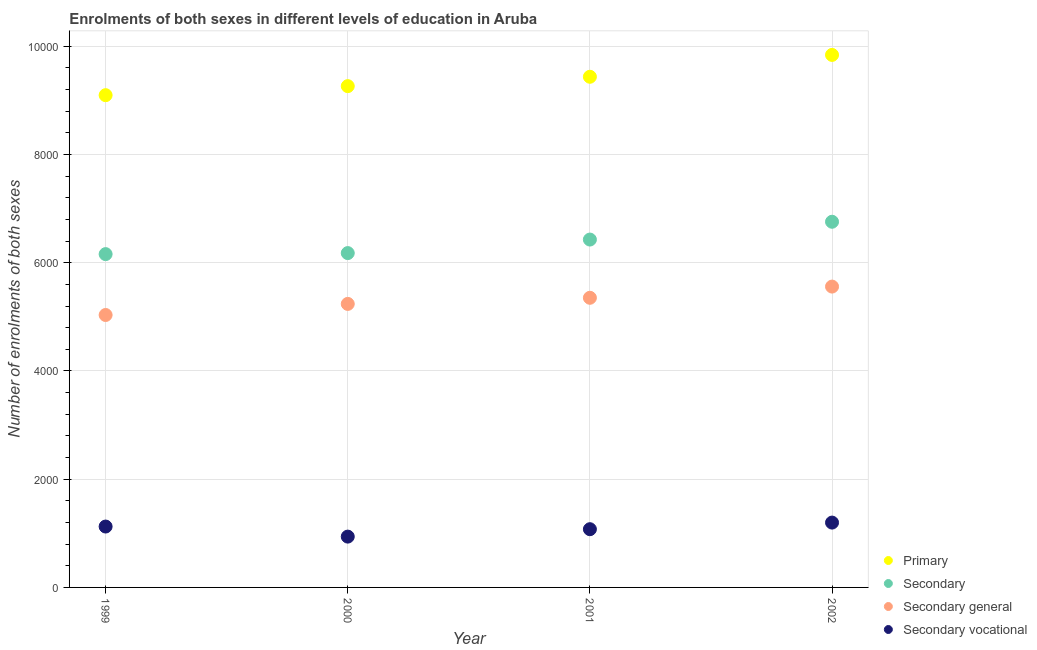How many different coloured dotlines are there?
Your answer should be compact. 4. Is the number of dotlines equal to the number of legend labels?
Keep it short and to the point. Yes. What is the number of enrolments in primary education in 2000?
Make the answer very short. 9263. Across all years, what is the maximum number of enrolments in secondary general education?
Your answer should be compact. 5559. Across all years, what is the minimum number of enrolments in secondary education?
Provide a succinct answer. 6159. What is the total number of enrolments in secondary education in the graph?
Provide a short and direct response. 2.55e+04. What is the difference between the number of enrolments in secondary education in 2001 and that in 2002?
Keep it short and to the point. -329. What is the difference between the number of enrolments in secondary vocational education in 2001 and the number of enrolments in secondary education in 1999?
Your response must be concise. -5083. What is the average number of enrolments in secondary general education per year?
Offer a very short reply. 5296. In the year 2002, what is the difference between the number of enrolments in secondary education and number of enrolments in secondary general education?
Provide a succinct answer. 1198. In how many years, is the number of enrolments in secondary education greater than 8000?
Provide a succinct answer. 0. What is the ratio of the number of enrolments in secondary education in 1999 to that in 2000?
Make the answer very short. 1. Is the difference between the number of enrolments in secondary vocational education in 2000 and 2001 greater than the difference between the number of enrolments in primary education in 2000 and 2001?
Keep it short and to the point. Yes. What is the difference between the highest and the second highest number of enrolments in primary education?
Make the answer very short. 404. What is the difference between the highest and the lowest number of enrolments in secondary education?
Your answer should be compact. 598. Is the sum of the number of enrolments in secondary vocational education in 1999 and 2000 greater than the maximum number of enrolments in primary education across all years?
Make the answer very short. No. Is it the case that in every year, the sum of the number of enrolments in primary education and number of enrolments in secondary education is greater than the number of enrolments in secondary general education?
Give a very brief answer. Yes. Is the number of enrolments in primary education strictly greater than the number of enrolments in secondary education over the years?
Ensure brevity in your answer.  Yes. How many dotlines are there?
Your answer should be very brief. 4. How many years are there in the graph?
Ensure brevity in your answer.  4. Are the values on the major ticks of Y-axis written in scientific E-notation?
Provide a succinct answer. No. Does the graph contain any zero values?
Ensure brevity in your answer.  No. Does the graph contain grids?
Offer a terse response. Yes. What is the title of the graph?
Offer a terse response. Enrolments of both sexes in different levels of education in Aruba. Does "Industry" appear as one of the legend labels in the graph?
Offer a very short reply. No. What is the label or title of the Y-axis?
Ensure brevity in your answer.  Number of enrolments of both sexes. What is the Number of enrolments of both sexes in Primary in 1999?
Ensure brevity in your answer.  9096. What is the Number of enrolments of both sexes of Secondary in 1999?
Offer a very short reply. 6159. What is the Number of enrolments of both sexes of Secondary general in 1999?
Provide a succinct answer. 5034. What is the Number of enrolments of both sexes in Secondary vocational in 1999?
Keep it short and to the point. 1125. What is the Number of enrolments of both sexes in Primary in 2000?
Offer a very short reply. 9263. What is the Number of enrolments of both sexes in Secondary in 2000?
Keep it short and to the point. 6178. What is the Number of enrolments of both sexes of Secondary general in 2000?
Provide a succinct answer. 5239. What is the Number of enrolments of both sexes of Secondary vocational in 2000?
Your answer should be compact. 939. What is the Number of enrolments of both sexes of Primary in 2001?
Offer a very short reply. 9436. What is the Number of enrolments of both sexes in Secondary in 2001?
Provide a short and direct response. 6428. What is the Number of enrolments of both sexes in Secondary general in 2001?
Provide a succinct answer. 5352. What is the Number of enrolments of both sexes in Secondary vocational in 2001?
Make the answer very short. 1076. What is the Number of enrolments of both sexes in Primary in 2002?
Make the answer very short. 9840. What is the Number of enrolments of both sexes in Secondary in 2002?
Your answer should be very brief. 6757. What is the Number of enrolments of both sexes in Secondary general in 2002?
Your response must be concise. 5559. What is the Number of enrolments of both sexes in Secondary vocational in 2002?
Provide a succinct answer. 1198. Across all years, what is the maximum Number of enrolments of both sexes of Primary?
Provide a short and direct response. 9840. Across all years, what is the maximum Number of enrolments of both sexes of Secondary?
Your answer should be compact. 6757. Across all years, what is the maximum Number of enrolments of both sexes in Secondary general?
Offer a terse response. 5559. Across all years, what is the maximum Number of enrolments of both sexes in Secondary vocational?
Provide a short and direct response. 1198. Across all years, what is the minimum Number of enrolments of both sexes in Primary?
Your response must be concise. 9096. Across all years, what is the minimum Number of enrolments of both sexes in Secondary?
Offer a very short reply. 6159. Across all years, what is the minimum Number of enrolments of both sexes in Secondary general?
Make the answer very short. 5034. Across all years, what is the minimum Number of enrolments of both sexes of Secondary vocational?
Your answer should be compact. 939. What is the total Number of enrolments of both sexes in Primary in the graph?
Your answer should be compact. 3.76e+04. What is the total Number of enrolments of both sexes in Secondary in the graph?
Your answer should be compact. 2.55e+04. What is the total Number of enrolments of both sexes in Secondary general in the graph?
Give a very brief answer. 2.12e+04. What is the total Number of enrolments of both sexes of Secondary vocational in the graph?
Give a very brief answer. 4338. What is the difference between the Number of enrolments of both sexes of Primary in 1999 and that in 2000?
Keep it short and to the point. -167. What is the difference between the Number of enrolments of both sexes in Secondary general in 1999 and that in 2000?
Offer a very short reply. -205. What is the difference between the Number of enrolments of both sexes of Secondary vocational in 1999 and that in 2000?
Give a very brief answer. 186. What is the difference between the Number of enrolments of both sexes in Primary in 1999 and that in 2001?
Provide a short and direct response. -340. What is the difference between the Number of enrolments of both sexes of Secondary in 1999 and that in 2001?
Ensure brevity in your answer.  -269. What is the difference between the Number of enrolments of both sexes of Secondary general in 1999 and that in 2001?
Your response must be concise. -318. What is the difference between the Number of enrolments of both sexes of Primary in 1999 and that in 2002?
Offer a terse response. -744. What is the difference between the Number of enrolments of both sexes in Secondary in 1999 and that in 2002?
Offer a very short reply. -598. What is the difference between the Number of enrolments of both sexes in Secondary general in 1999 and that in 2002?
Offer a terse response. -525. What is the difference between the Number of enrolments of both sexes of Secondary vocational in 1999 and that in 2002?
Keep it short and to the point. -73. What is the difference between the Number of enrolments of both sexes of Primary in 2000 and that in 2001?
Provide a short and direct response. -173. What is the difference between the Number of enrolments of both sexes in Secondary in 2000 and that in 2001?
Give a very brief answer. -250. What is the difference between the Number of enrolments of both sexes of Secondary general in 2000 and that in 2001?
Your answer should be compact. -113. What is the difference between the Number of enrolments of both sexes of Secondary vocational in 2000 and that in 2001?
Your answer should be very brief. -137. What is the difference between the Number of enrolments of both sexes of Primary in 2000 and that in 2002?
Provide a succinct answer. -577. What is the difference between the Number of enrolments of both sexes of Secondary in 2000 and that in 2002?
Keep it short and to the point. -579. What is the difference between the Number of enrolments of both sexes in Secondary general in 2000 and that in 2002?
Give a very brief answer. -320. What is the difference between the Number of enrolments of both sexes in Secondary vocational in 2000 and that in 2002?
Your answer should be compact. -259. What is the difference between the Number of enrolments of both sexes of Primary in 2001 and that in 2002?
Ensure brevity in your answer.  -404. What is the difference between the Number of enrolments of both sexes of Secondary in 2001 and that in 2002?
Your response must be concise. -329. What is the difference between the Number of enrolments of both sexes in Secondary general in 2001 and that in 2002?
Provide a short and direct response. -207. What is the difference between the Number of enrolments of both sexes of Secondary vocational in 2001 and that in 2002?
Offer a very short reply. -122. What is the difference between the Number of enrolments of both sexes of Primary in 1999 and the Number of enrolments of both sexes of Secondary in 2000?
Keep it short and to the point. 2918. What is the difference between the Number of enrolments of both sexes in Primary in 1999 and the Number of enrolments of both sexes in Secondary general in 2000?
Give a very brief answer. 3857. What is the difference between the Number of enrolments of both sexes of Primary in 1999 and the Number of enrolments of both sexes of Secondary vocational in 2000?
Keep it short and to the point. 8157. What is the difference between the Number of enrolments of both sexes in Secondary in 1999 and the Number of enrolments of both sexes in Secondary general in 2000?
Your answer should be very brief. 920. What is the difference between the Number of enrolments of both sexes in Secondary in 1999 and the Number of enrolments of both sexes in Secondary vocational in 2000?
Keep it short and to the point. 5220. What is the difference between the Number of enrolments of both sexes in Secondary general in 1999 and the Number of enrolments of both sexes in Secondary vocational in 2000?
Give a very brief answer. 4095. What is the difference between the Number of enrolments of both sexes in Primary in 1999 and the Number of enrolments of both sexes in Secondary in 2001?
Offer a very short reply. 2668. What is the difference between the Number of enrolments of both sexes in Primary in 1999 and the Number of enrolments of both sexes in Secondary general in 2001?
Your answer should be compact. 3744. What is the difference between the Number of enrolments of both sexes of Primary in 1999 and the Number of enrolments of both sexes of Secondary vocational in 2001?
Give a very brief answer. 8020. What is the difference between the Number of enrolments of both sexes in Secondary in 1999 and the Number of enrolments of both sexes in Secondary general in 2001?
Give a very brief answer. 807. What is the difference between the Number of enrolments of both sexes in Secondary in 1999 and the Number of enrolments of both sexes in Secondary vocational in 2001?
Provide a succinct answer. 5083. What is the difference between the Number of enrolments of both sexes in Secondary general in 1999 and the Number of enrolments of both sexes in Secondary vocational in 2001?
Give a very brief answer. 3958. What is the difference between the Number of enrolments of both sexes in Primary in 1999 and the Number of enrolments of both sexes in Secondary in 2002?
Offer a terse response. 2339. What is the difference between the Number of enrolments of both sexes in Primary in 1999 and the Number of enrolments of both sexes in Secondary general in 2002?
Your answer should be compact. 3537. What is the difference between the Number of enrolments of both sexes of Primary in 1999 and the Number of enrolments of both sexes of Secondary vocational in 2002?
Offer a terse response. 7898. What is the difference between the Number of enrolments of both sexes of Secondary in 1999 and the Number of enrolments of both sexes of Secondary general in 2002?
Keep it short and to the point. 600. What is the difference between the Number of enrolments of both sexes in Secondary in 1999 and the Number of enrolments of both sexes in Secondary vocational in 2002?
Offer a very short reply. 4961. What is the difference between the Number of enrolments of both sexes in Secondary general in 1999 and the Number of enrolments of both sexes in Secondary vocational in 2002?
Provide a short and direct response. 3836. What is the difference between the Number of enrolments of both sexes of Primary in 2000 and the Number of enrolments of both sexes of Secondary in 2001?
Your response must be concise. 2835. What is the difference between the Number of enrolments of both sexes in Primary in 2000 and the Number of enrolments of both sexes in Secondary general in 2001?
Provide a short and direct response. 3911. What is the difference between the Number of enrolments of both sexes in Primary in 2000 and the Number of enrolments of both sexes in Secondary vocational in 2001?
Your answer should be compact. 8187. What is the difference between the Number of enrolments of both sexes in Secondary in 2000 and the Number of enrolments of both sexes in Secondary general in 2001?
Keep it short and to the point. 826. What is the difference between the Number of enrolments of both sexes in Secondary in 2000 and the Number of enrolments of both sexes in Secondary vocational in 2001?
Your response must be concise. 5102. What is the difference between the Number of enrolments of both sexes in Secondary general in 2000 and the Number of enrolments of both sexes in Secondary vocational in 2001?
Your response must be concise. 4163. What is the difference between the Number of enrolments of both sexes of Primary in 2000 and the Number of enrolments of both sexes of Secondary in 2002?
Offer a very short reply. 2506. What is the difference between the Number of enrolments of both sexes in Primary in 2000 and the Number of enrolments of both sexes in Secondary general in 2002?
Ensure brevity in your answer.  3704. What is the difference between the Number of enrolments of both sexes in Primary in 2000 and the Number of enrolments of both sexes in Secondary vocational in 2002?
Provide a succinct answer. 8065. What is the difference between the Number of enrolments of both sexes in Secondary in 2000 and the Number of enrolments of both sexes in Secondary general in 2002?
Give a very brief answer. 619. What is the difference between the Number of enrolments of both sexes of Secondary in 2000 and the Number of enrolments of both sexes of Secondary vocational in 2002?
Keep it short and to the point. 4980. What is the difference between the Number of enrolments of both sexes in Secondary general in 2000 and the Number of enrolments of both sexes in Secondary vocational in 2002?
Offer a terse response. 4041. What is the difference between the Number of enrolments of both sexes of Primary in 2001 and the Number of enrolments of both sexes of Secondary in 2002?
Offer a very short reply. 2679. What is the difference between the Number of enrolments of both sexes of Primary in 2001 and the Number of enrolments of both sexes of Secondary general in 2002?
Provide a succinct answer. 3877. What is the difference between the Number of enrolments of both sexes of Primary in 2001 and the Number of enrolments of both sexes of Secondary vocational in 2002?
Offer a terse response. 8238. What is the difference between the Number of enrolments of both sexes in Secondary in 2001 and the Number of enrolments of both sexes in Secondary general in 2002?
Your answer should be very brief. 869. What is the difference between the Number of enrolments of both sexes in Secondary in 2001 and the Number of enrolments of both sexes in Secondary vocational in 2002?
Give a very brief answer. 5230. What is the difference between the Number of enrolments of both sexes of Secondary general in 2001 and the Number of enrolments of both sexes of Secondary vocational in 2002?
Offer a terse response. 4154. What is the average Number of enrolments of both sexes in Primary per year?
Ensure brevity in your answer.  9408.75. What is the average Number of enrolments of both sexes in Secondary per year?
Give a very brief answer. 6380.5. What is the average Number of enrolments of both sexes in Secondary general per year?
Make the answer very short. 5296. What is the average Number of enrolments of both sexes in Secondary vocational per year?
Your answer should be very brief. 1084.5. In the year 1999, what is the difference between the Number of enrolments of both sexes in Primary and Number of enrolments of both sexes in Secondary?
Provide a succinct answer. 2937. In the year 1999, what is the difference between the Number of enrolments of both sexes of Primary and Number of enrolments of both sexes of Secondary general?
Ensure brevity in your answer.  4062. In the year 1999, what is the difference between the Number of enrolments of both sexes in Primary and Number of enrolments of both sexes in Secondary vocational?
Your answer should be very brief. 7971. In the year 1999, what is the difference between the Number of enrolments of both sexes of Secondary and Number of enrolments of both sexes of Secondary general?
Give a very brief answer. 1125. In the year 1999, what is the difference between the Number of enrolments of both sexes in Secondary and Number of enrolments of both sexes in Secondary vocational?
Your response must be concise. 5034. In the year 1999, what is the difference between the Number of enrolments of both sexes in Secondary general and Number of enrolments of both sexes in Secondary vocational?
Your answer should be compact. 3909. In the year 2000, what is the difference between the Number of enrolments of both sexes of Primary and Number of enrolments of both sexes of Secondary?
Give a very brief answer. 3085. In the year 2000, what is the difference between the Number of enrolments of both sexes of Primary and Number of enrolments of both sexes of Secondary general?
Provide a succinct answer. 4024. In the year 2000, what is the difference between the Number of enrolments of both sexes of Primary and Number of enrolments of both sexes of Secondary vocational?
Your response must be concise. 8324. In the year 2000, what is the difference between the Number of enrolments of both sexes of Secondary and Number of enrolments of both sexes of Secondary general?
Provide a succinct answer. 939. In the year 2000, what is the difference between the Number of enrolments of both sexes of Secondary and Number of enrolments of both sexes of Secondary vocational?
Your answer should be very brief. 5239. In the year 2000, what is the difference between the Number of enrolments of both sexes of Secondary general and Number of enrolments of both sexes of Secondary vocational?
Offer a very short reply. 4300. In the year 2001, what is the difference between the Number of enrolments of both sexes of Primary and Number of enrolments of both sexes of Secondary?
Your answer should be very brief. 3008. In the year 2001, what is the difference between the Number of enrolments of both sexes in Primary and Number of enrolments of both sexes in Secondary general?
Ensure brevity in your answer.  4084. In the year 2001, what is the difference between the Number of enrolments of both sexes of Primary and Number of enrolments of both sexes of Secondary vocational?
Provide a succinct answer. 8360. In the year 2001, what is the difference between the Number of enrolments of both sexes in Secondary and Number of enrolments of both sexes in Secondary general?
Your response must be concise. 1076. In the year 2001, what is the difference between the Number of enrolments of both sexes of Secondary and Number of enrolments of both sexes of Secondary vocational?
Your answer should be compact. 5352. In the year 2001, what is the difference between the Number of enrolments of both sexes in Secondary general and Number of enrolments of both sexes in Secondary vocational?
Provide a succinct answer. 4276. In the year 2002, what is the difference between the Number of enrolments of both sexes in Primary and Number of enrolments of both sexes in Secondary?
Your answer should be compact. 3083. In the year 2002, what is the difference between the Number of enrolments of both sexes in Primary and Number of enrolments of both sexes in Secondary general?
Keep it short and to the point. 4281. In the year 2002, what is the difference between the Number of enrolments of both sexes of Primary and Number of enrolments of both sexes of Secondary vocational?
Provide a short and direct response. 8642. In the year 2002, what is the difference between the Number of enrolments of both sexes in Secondary and Number of enrolments of both sexes in Secondary general?
Offer a terse response. 1198. In the year 2002, what is the difference between the Number of enrolments of both sexes of Secondary and Number of enrolments of both sexes of Secondary vocational?
Your answer should be compact. 5559. In the year 2002, what is the difference between the Number of enrolments of both sexes in Secondary general and Number of enrolments of both sexes in Secondary vocational?
Your answer should be very brief. 4361. What is the ratio of the Number of enrolments of both sexes in Primary in 1999 to that in 2000?
Provide a succinct answer. 0.98. What is the ratio of the Number of enrolments of both sexes in Secondary general in 1999 to that in 2000?
Provide a short and direct response. 0.96. What is the ratio of the Number of enrolments of both sexes in Secondary vocational in 1999 to that in 2000?
Ensure brevity in your answer.  1.2. What is the ratio of the Number of enrolments of both sexes in Secondary in 1999 to that in 2001?
Keep it short and to the point. 0.96. What is the ratio of the Number of enrolments of both sexes of Secondary general in 1999 to that in 2001?
Your response must be concise. 0.94. What is the ratio of the Number of enrolments of both sexes in Secondary vocational in 1999 to that in 2001?
Your answer should be compact. 1.05. What is the ratio of the Number of enrolments of both sexes of Primary in 1999 to that in 2002?
Your response must be concise. 0.92. What is the ratio of the Number of enrolments of both sexes of Secondary in 1999 to that in 2002?
Your answer should be compact. 0.91. What is the ratio of the Number of enrolments of both sexes of Secondary general in 1999 to that in 2002?
Your answer should be very brief. 0.91. What is the ratio of the Number of enrolments of both sexes of Secondary vocational in 1999 to that in 2002?
Ensure brevity in your answer.  0.94. What is the ratio of the Number of enrolments of both sexes of Primary in 2000 to that in 2001?
Your answer should be very brief. 0.98. What is the ratio of the Number of enrolments of both sexes of Secondary in 2000 to that in 2001?
Make the answer very short. 0.96. What is the ratio of the Number of enrolments of both sexes in Secondary general in 2000 to that in 2001?
Your response must be concise. 0.98. What is the ratio of the Number of enrolments of both sexes of Secondary vocational in 2000 to that in 2001?
Your answer should be compact. 0.87. What is the ratio of the Number of enrolments of both sexes of Primary in 2000 to that in 2002?
Make the answer very short. 0.94. What is the ratio of the Number of enrolments of both sexes of Secondary in 2000 to that in 2002?
Provide a short and direct response. 0.91. What is the ratio of the Number of enrolments of both sexes in Secondary general in 2000 to that in 2002?
Give a very brief answer. 0.94. What is the ratio of the Number of enrolments of both sexes in Secondary vocational in 2000 to that in 2002?
Offer a terse response. 0.78. What is the ratio of the Number of enrolments of both sexes in Primary in 2001 to that in 2002?
Your answer should be compact. 0.96. What is the ratio of the Number of enrolments of both sexes in Secondary in 2001 to that in 2002?
Make the answer very short. 0.95. What is the ratio of the Number of enrolments of both sexes in Secondary general in 2001 to that in 2002?
Provide a succinct answer. 0.96. What is the ratio of the Number of enrolments of both sexes of Secondary vocational in 2001 to that in 2002?
Your answer should be compact. 0.9. What is the difference between the highest and the second highest Number of enrolments of both sexes of Primary?
Your response must be concise. 404. What is the difference between the highest and the second highest Number of enrolments of both sexes of Secondary?
Offer a very short reply. 329. What is the difference between the highest and the second highest Number of enrolments of both sexes in Secondary general?
Keep it short and to the point. 207. What is the difference between the highest and the lowest Number of enrolments of both sexes in Primary?
Give a very brief answer. 744. What is the difference between the highest and the lowest Number of enrolments of both sexes in Secondary?
Ensure brevity in your answer.  598. What is the difference between the highest and the lowest Number of enrolments of both sexes of Secondary general?
Offer a terse response. 525. What is the difference between the highest and the lowest Number of enrolments of both sexes in Secondary vocational?
Your response must be concise. 259. 